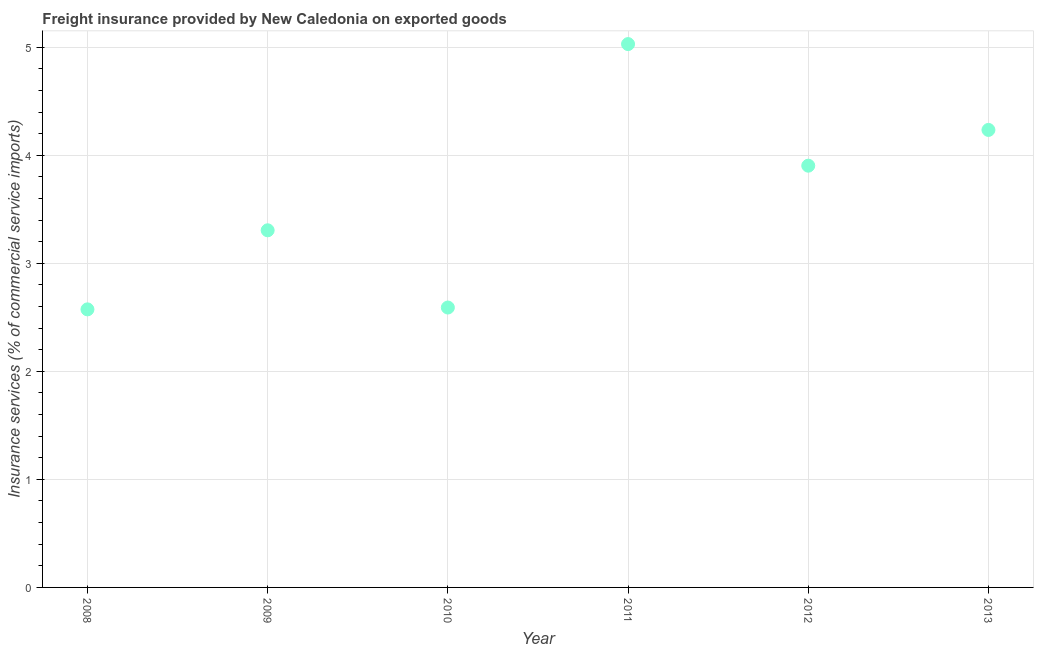What is the freight insurance in 2010?
Your response must be concise. 2.59. Across all years, what is the maximum freight insurance?
Your answer should be compact. 5.03. Across all years, what is the minimum freight insurance?
Provide a short and direct response. 2.57. In which year was the freight insurance minimum?
Provide a short and direct response. 2008. What is the sum of the freight insurance?
Offer a terse response. 21.63. What is the difference between the freight insurance in 2011 and 2013?
Offer a terse response. 0.79. What is the average freight insurance per year?
Provide a succinct answer. 3.61. What is the median freight insurance?
Offer a terse response. 3.6. What is the ratio of the freight insurance in 2010 to that in 2012?
Provide a succinct answer. 0.66. Is the freight insurance in 2010 less than that in 2013?
Your answer should be compact. Yes. What is the difference between the highest and the second highest freight insurance?
Ensure brevity in your answer.  0.79. Is the sum of the freight insurance in 2009 and 2012 greater than the maximum freight insurance across all years?
Your answer should be compact. Yes. What is the difference between the highest and the lowest freight insurance?
Give a very brief answer. 2.46. In how many years, is the freight insurance greater than the average freight insurance taken over all years?
Offer a very short reply. 3. Does the freight insurance monotonically increase over the years?
Your answer should be very brief. No. What is the difference between two consecutive major ticks on the Y-axis?
Ensure brevity in your answer.  1. Does the graph contain grids?
Provide a short and direct response. Yes. What is the title of the graph?
Make the answer very short. Freight insurance provided by New Caledonia on exported goods . What is the label or title of the X-axis?
Make the answer very short. Year. What is the label or title of the Y-axis?
Provide a short and direct response. Insurance services (% of commercial service imports). What is the Insurance services (% of commercial service imports) in 2008?
Offer a terse response. 2.57. What is the Insurance services (% of commercial service imports) in 2009?
Keep it short and to the point. 3.31. What is the Insurance services (% of commercial service imports) in 2010?
Your response must be concise. 2.59. What is the Insurance services (% of commercial service imports) in 2011?
Provide a succinct answer. 5.03. What is the Insurance services (% of commercial service imports) in 2012?
Give a very brief answer. 3.9. What is the Insurance services (% of commercial service imports) in 2013?
Make the answer very short. 4.23. What is the difference between the Insurance services (% of commercial service imports) in 2008 and 2009?
Your answer should be very brief. -0.73. What is the difference between the Insurance services (% of commercial service imports) in 2008 and 2010?
Give a very brief answer. -0.02. What is the difference between the Insurance services (% of commercial service imports) in 2008 and 2011?
Your response must be concise. -2.46. What is the difference between the Insurance services (% of commercial service imports) in 2008 and 2012?
Your response must be concise. -1.33. What is the difference between the Insurance services (% of commercial service imports) in 2008 and 2013?
Provide a short and direct response. -1.66. What is the difference between the Insurance services (% of commercial service imports) in 2009 and 2010?
Provide a short and direct response. 0.71. What is the difference between the Insurance services (% of commercial service imports) in 2009 and 2011?
Keep it short and to the point. -1.72. What is the difference between the Insurance services (% of commercial service imports) in 2009 and 2012?
Make the answer very short. -0.6. What is the difference between the Insurance services (% of commercial service imports) in 2009 and 2013?
Offer a terse response. -0.93. What is the difference between the Insurance services (% of commercial service imports) in 2010 and 2011?
Keep it short and to the point. -2.44. What is the difference between the Insurance services (% of commercial service imports) in 2010 and 2012?
Keep it short and to the point. -1.31. What is the difference between the Insurance services (% of commercial service imports) in 2010 and 2013?
Your response must be concise. -1.64. What is the difference between the Insurance services (% of commercial service imports) in 2011 and 2012?
Offer a very short reply. 1.13. What is the difference between the Insurance services (% of commercial service imports) in 2011 and 2013?
Offer a very short reply. 0.79. What is the difference between the Insurance services (% of commercial service imports) in 2012 and 2013?
Offer a very short reply. -0.33. What is the ratio of the Insurance services (% of commercial service imports) in 2008 to that in 2009?
Offer a very short reply. 0.78. What is the ratio of the Insurance services (% of commercial service imports) in 2008 to that in 2011?
Your response must be concise. 0.51. What is the ratio of the Insurance services (% of commercial service imports) in 2008 to that in 2012?
Offer a terse response. 0.66. What is the ratio of the Insurance services (% of commercial service imports) in 2008 to that in 2013?
Provide a short and direct response. 0.61. What is the ratio of the Insurance services (% of commercial service imports) in 2009 to that in 2010?
Your response must be concise. 1.28. What is the ratio of the Insurance services (% of commercial service imports) in 2009 to that in 2011?
Provide a succinct answer. 0.66. What is the ratio of the Insurance services (% of commercial service imports) in 2009 to that in 2012?
Offer a very short reply. 0.85. What is the ratio of the Insurance services (% of commercial service imports) in 2009 to that in 2013?
Your answer should be compact. 0.78. What is the ratio of the Insurance services (% of commercial service imports) in 2010 to that in 2011?
Keep it short and to the point. 0.52. What is the ratio of the Insurance services (% of commercial service imports) in 2010 to that in 2012?
Offer a terse response. 0.66. What is the ratio of the Insurance services (% of commercial service imports) in 2010 to that in 2013?
Make the answer very short. 0.61. What is the ratio of the Insurance services (% of commercial service imports) in 2011 to that in 2012?
Provide a short and direct response. 1.29. What is the ratio of the Insurance services (% of commercial service imports) in 2011 to that in 2013?
Make the answer very short. 1.19. What is the ratio of the Insurance services (% of commercial service imports) in 2012 to that in 2013?
Your response must be concise. 0.92. 